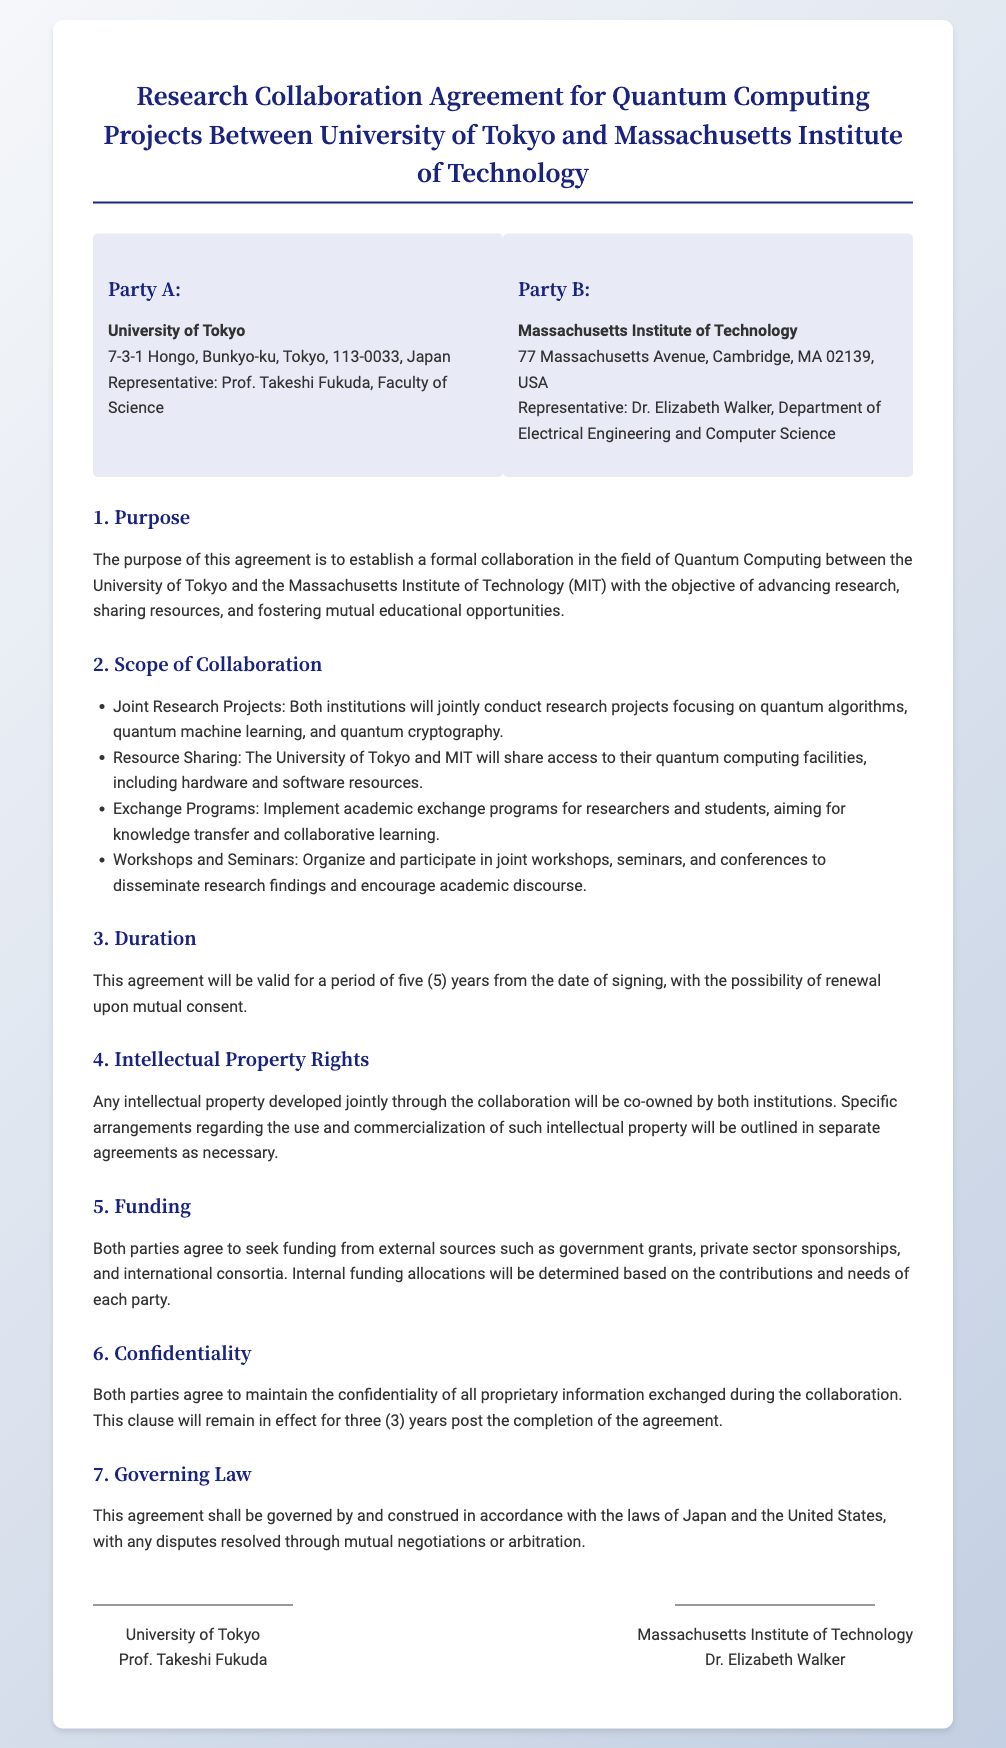What is the name of Party A? Party A is the University of Tokyo as noted in the agreement.
Answer: University of Tokyo Who is the representative of MIT? The representative of MIT, mentioned in the contract, is Dr. Elizabeth Walker.
Answer: Dr. Elizabeth Walker How long is the duration of the agreement? The agreement states that it will be valid for a period of five years.
Answer: Five years What is the primary purpose of the agreement? The purpose outlined in the document is to establish formal collaboration in the field of Quantum Computing.
Answer: Establish a formal collaboration in Quantum Computing What are the key areas of focus for joint research projects? The document lists several areas of focus including quantum algorithms, quantum machine learning, and quantum cryptography.
Answer: Quantum algorithms, quantum machine learning, quantum cryptography What must be sought for funding according to the agreement? The agreement specifies that both parties agree to seek funding from external sources.
Answer: External sources What will happen to intellectual property developed jointly? The document indicates that any jointly developed intellectual property will be co-owned by both institutions.
Answer: Co-owned How long will the confidentiality clause remain in effect? The confidentiality clause will remain in effect for three years post completion of the agreement.
Answer: Three years What laws govern this agreement? The governing laws mentioned in the agreement are those of Japan and the United States.
Answer: Japan and the United States 